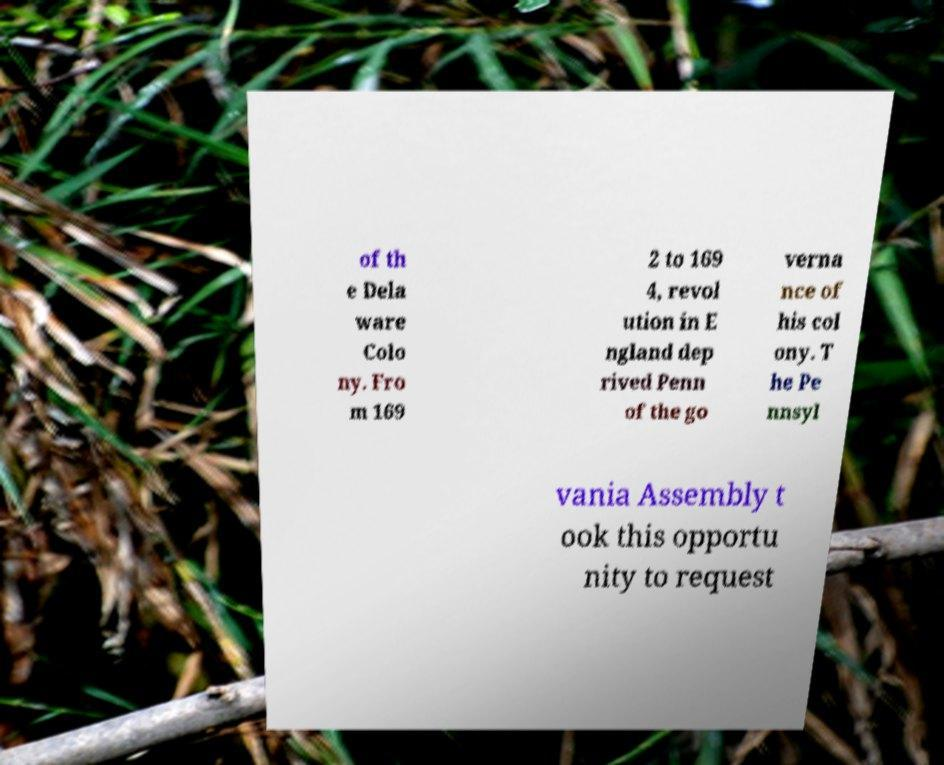There's text embedded in this image that I need extracted. Can you transcribe it verbatim? of th e Dela ware Colo ny. Fro m 169 2 to 169 4, revol ution in E ngland dep rived Penn of the go verna nce of his col ony. T he Pe nnsyl vania Assembly t ook this opportu nity to request 